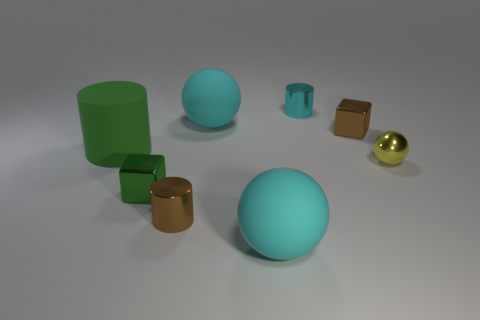Is there a cyan thing made of the same material as the cyan cylinder? Yes, the large sphere in the center appears to be made of the same matte material as the cyan cylinder on the left. 